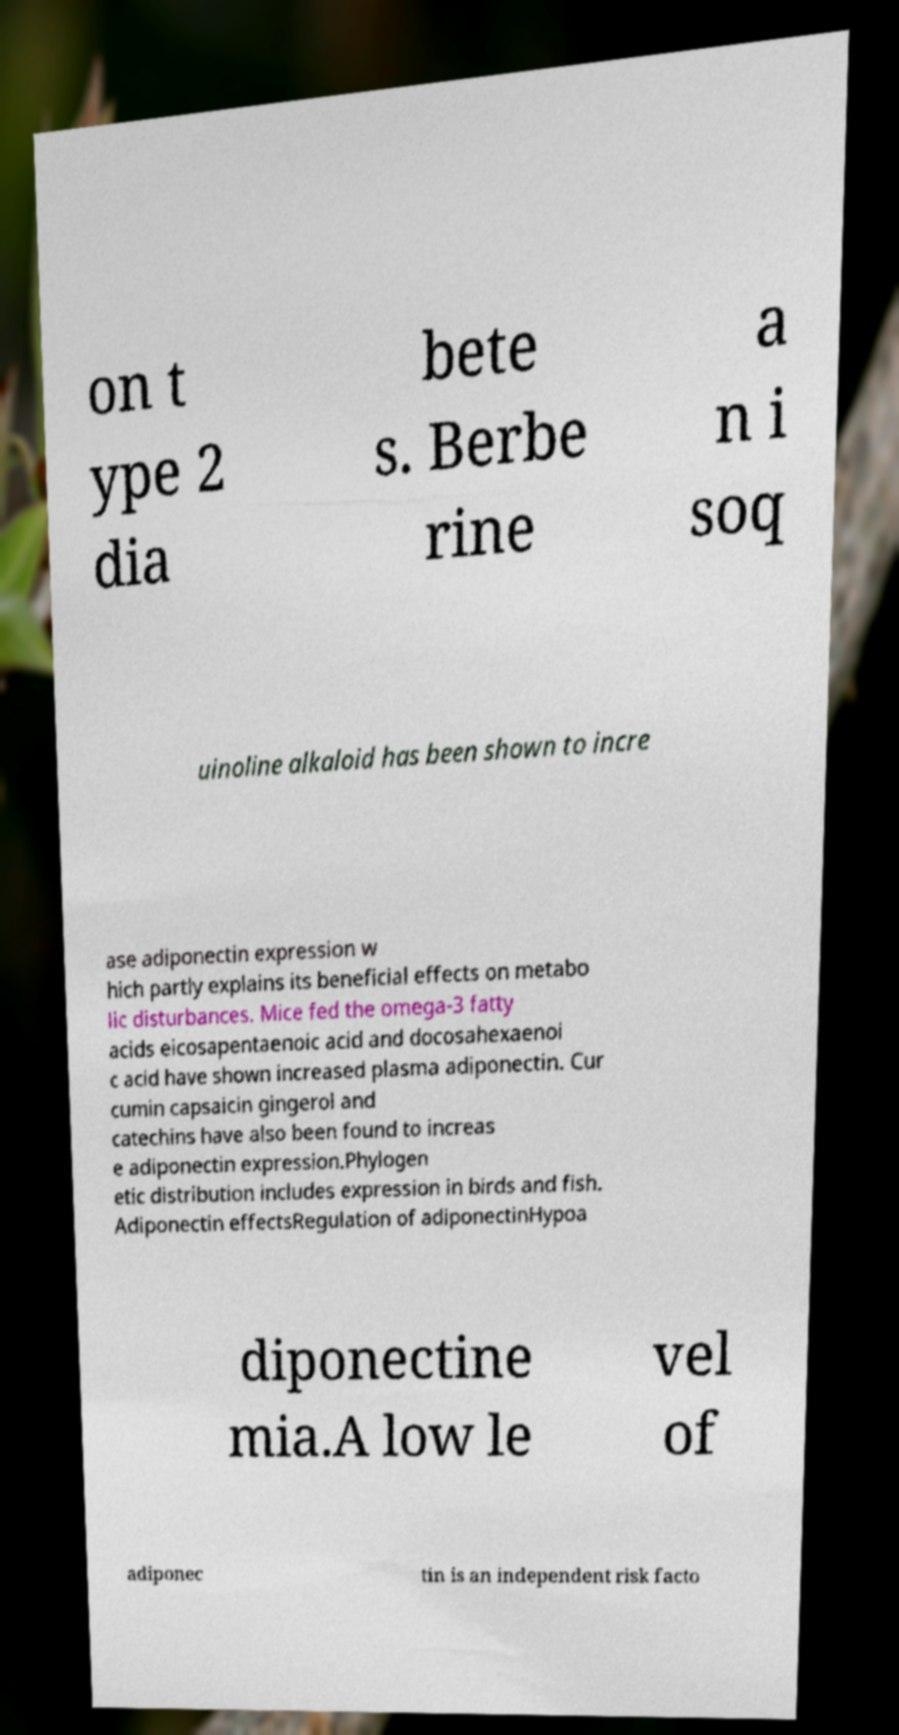Could you assist in decoding the text presented in this image and type it out clearly? on t ype 2 dia bete s. Berbe rine a n i soq uinoline alkaloid has been shown to incre ase adiponectin expression w hich partly explains its beneficial effects on metabo lic disturbances. Mice fed the omega-3 fatty acids eicosapentaenoic acid and docosahexaenoi c acid have shown increased plasma adiponectin. Cur cumin capsaicin gingerol and catechins have also been found to increas e adiponectin expression.Phylogen etic distribution includes expression in birds and fish. Adiponectin effectsRegulation of adiponectinHypoa diponectine mia.A low le vel of adiponec tin is an independent risk facto 